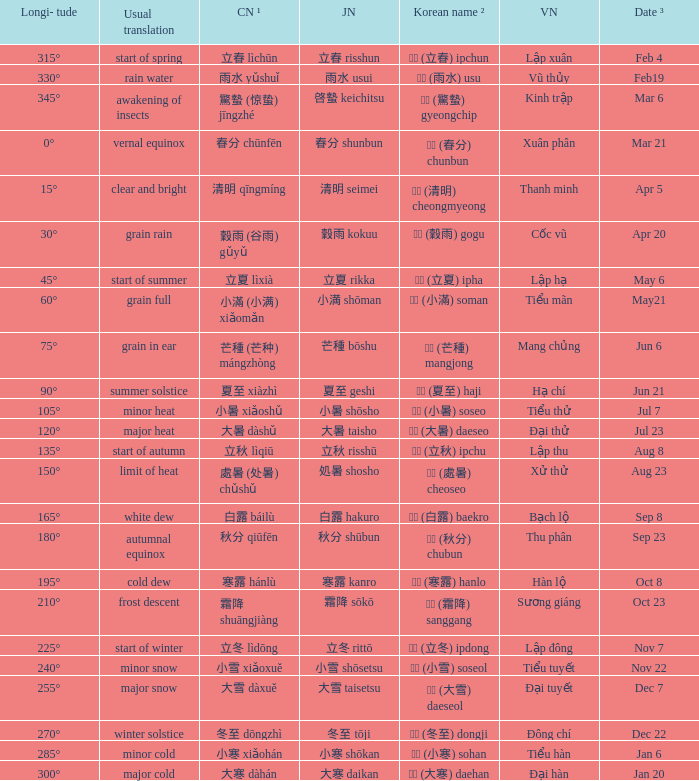Could you parse the entire table? {'header': ['Longi- tude', 'Usual translation', 'CN ¹', 'JN', 'Korean name ²', 'VN', 'Date ³'], 'rows': [['315°', 'start of spring', '立春 lìchūn', '立春 risshun', '입춘 (立春) ipchun', 'Lập xuân', 'Feb 4'], ['330°', 'rain water', '雨水 yǔshuǐ', '雨水 usui', '우수 (雨水) usu', 'Vũ thủy', 'Feb19'], ['345°', 'awakening of insects', '驚蟄 (惊蛰) jīngzhé', '啓蟄 keichitsu', '경칩 (驚蟄) gyeongchip', 'Kinh trập', 'Mar 6'], ['0°', 'vernal equinox', '春分 chūnfēn', '春分 shunbun', '춘분 (春分) chunbun', 'Xuân phân', 'Mar 21'], ['15°', 'clear and bright', '清明 qīngmíng', '清明 seimei', '청명 (清明) cheongmyeong', 'Thanh minh', 'Apr 5'], ['30°', 'grain rain', '穀雨 (谷雨) gǔyǔ', '穀雨 kokuu', '곡우 (穀雨) gogu', 'Cốc vũ', 'Apr 20'], ['45°', 'start of summer', '立夏 lìxià', '立夏 rikka', '입하 (立夏) ipha', 'Lập hạ', 'May 6'], ['60°', 'grain full', '小滿 (小满) xiǎomǎn', '小満 shōman', '소만 (小滿) soman', 'Tiểu mãn', 'May21'], ['75°', 'grain in ear', '芒種 (芒种) mángzhòng', '芒種 bōshu', '망종 (芒種) mangjong', 'Mang chủng', 'Jun 6'], ['90°', 'summer solstice', '夏至 xiàzhì', '夏至 geshi', '하지 (夏至) haji', 'Hạ chí', 'Jun 21'], ['105°', 'minor heat', '小暑 xiǎoshǔ', '小暑 shōsho', '소서 (小暑) soseo', 'Tiểu thử', 'Jul 7'], ['120°', 'major heat', '大暑 dàshǔ', '大暑 taisho', '대서 (大暑) daeseo', 'Đại thử', 'Jul 23'], ['135°', 'start of autumn', '立秋 lìqiū', '立秋 risshū', '입추 (立秋) ipchu', 'Lập thu', 'Aug 8'], ['150°', 'limit of heat', '處暑 (处暑) chǔshǔ', '処暑 shosho', '처서 (處暑) cheoseo', 'Xử thử', 'Aug 23'], ['165°', 'white dew', '白露 báilù', '白露 hakuro', '백로 (白露) baekro', 'Bạch lộ', 'Sep 8'], ['180°', 'autumnal equinox', '秋分 qiūfēn', '秋分 shūbun', '추분 (秋分) chubun', 'Thu phân', 'Sep 23'], ['195°', 'cold dew', '寒露 hánlù', '寒露 kanro', '한로 (寒露) hanlo', 'Hàn lộ', 'Oct 8'], ['210°', 'frost descent', '霜降 shuāngjiàng', '霜降 sōkō', '상강 (霜降) sanggang', 'Sương giáng', 'Oct 23'], ['225°', 'start of winter', '立冬 lìdōng', '立冬 rittō', '입동 (立冬) ipdong', 'Lập đông', 'Nov 7'], ['240°', 'minor snow', '小雪 xiǎoxuě', '小雪 shōsetsu', '소설 (小雪) soseol', 'Tiểu tuyết', 'Nov 22'], ['255°', 'major snow', '大雪 dàxuě', '大雪 taisetsu', '대설 (大雪) daeseol', 'Đại tuyết', 'Dec 7'], ['270°', 'winter solstice', '冬至 dōngzhì', '冬至 tōji', '동지 (冬至) dongji', 'Đông chí', 'Dec 22'], ['285°', 'minor cold', '小寒 xiǎohán', '小寒 shōkan', '소한 (小寒) sohan', 'Tiểu hàn', 'Jan 6'], ['300°', 'major cold', '大寒 dàhán', '大寒 daikan', '대한 (大寒) daehan', 'Đại hàn', 'Jan 20']]} WHICH Vietnamese name has a Chinese name ¹ of 芒種 (芒种) mángzhòng? Mang chủng. 